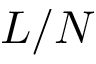<formula> <loc_0><loc_0><loc_500><loc_500>L / N</formula> 